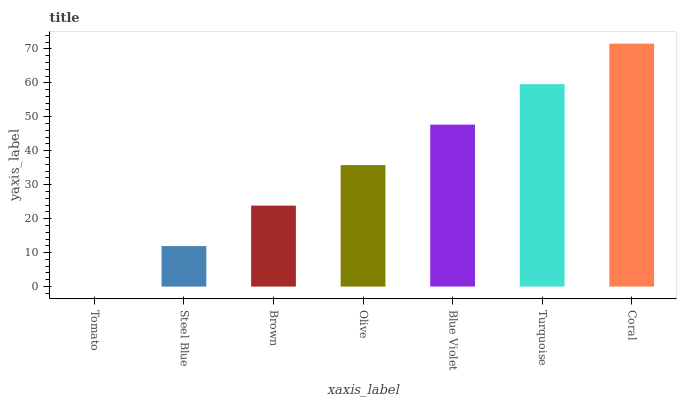Is Tomato the minimum?
Answer yes or no. Yes. Is Coral the maximum?
Answer yes or no. Yes. Is Steel Blue the minimum?
Answer yes or no. No. Is Steel Blue the maximum?
Answer yes or no. No. Is Steel Blue greater than Tomato?
Answer yes or no. Yes. Is Tomato less than Steel Blue?
Answer yes or no. Yes. Is Tomato greater than Steel Blue?
Answer yes or no. No. Is Steel Blue less than Tomato?
Answer yes or no. No. Is Olive the high median?
Answer yes or no. Yes. Is Olive the low median?
Answer yes or no. Yes. Is Steel Blue the high median?
Answer yes or no. No. Is Turquoise the low median?
Answer yes or no. No. 